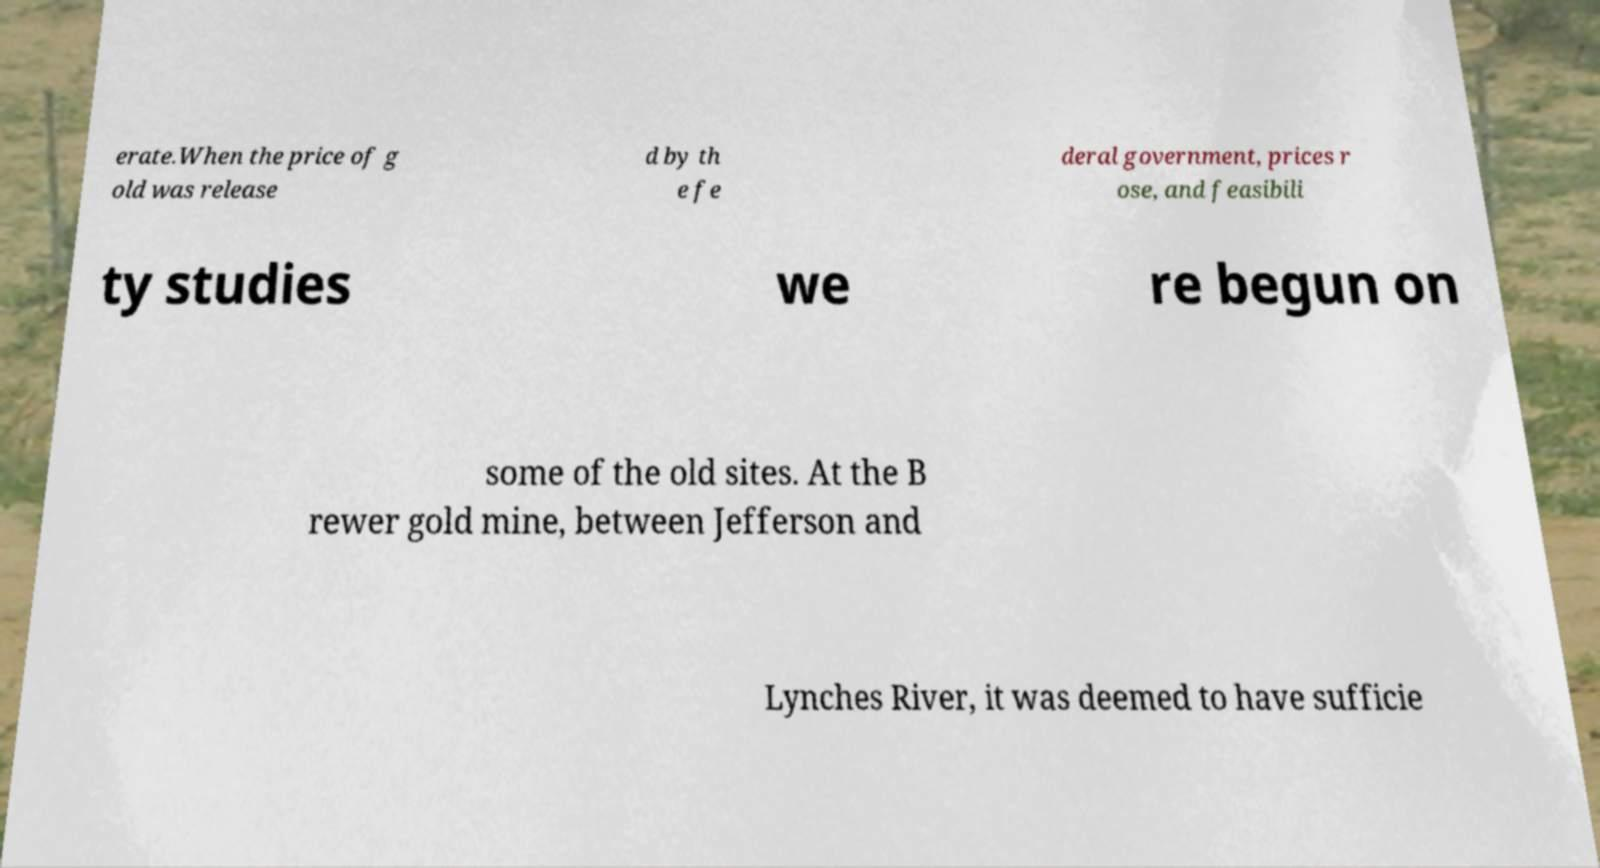Could you assist in decoding the text presented in this image and type it out clearly? erate.When the price of g old was release d by th e fe deral government, prices r ose, and feasibili ty studies we re begun on some of the old sites. At the B rewer gold mine, between Jefferson and Lynches River, it was deemed to have sufficie 